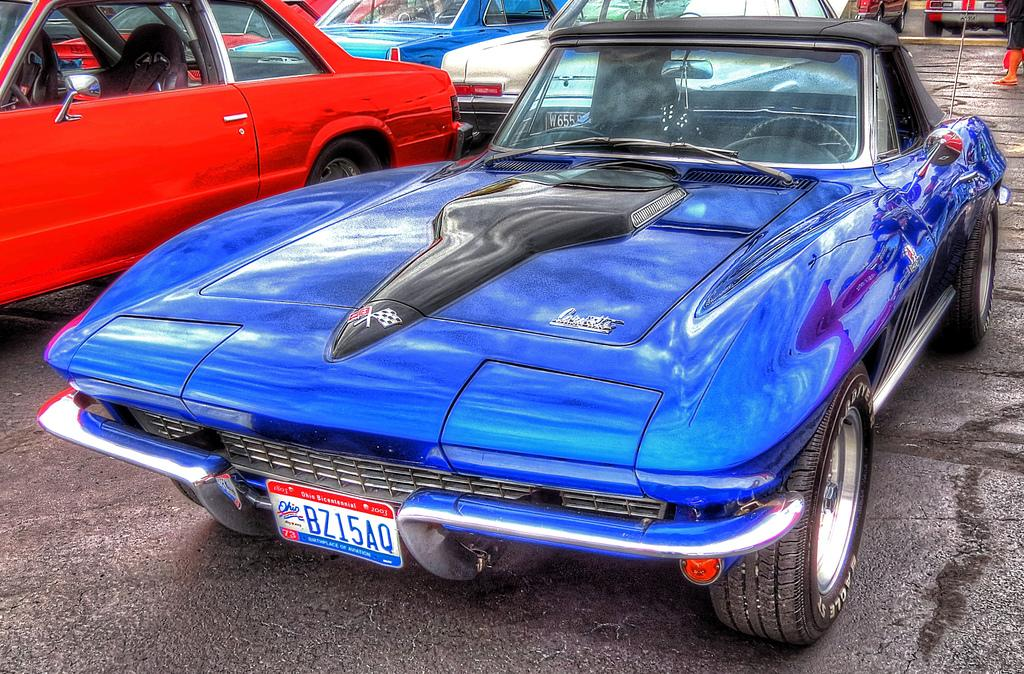What type of vehicles are on the ground in the image? There are cars on the ground in the image. Can you describe the color of the car in the front? The car in the front is blue in color. What can be seen in the background of the image? There are objects visible in the background of the image. What type of error can be seen on the page in the image? There is no page present in the image, so it is not possible to determine if there is an error or not. 